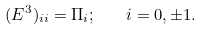Convert formula to latex. <formula><loc_0><loc_0><loc_500><loc_500>( E ^ { 3 } ) _ { i i } = \Pi _ { i } ; \quad i = 0 , \pm 1 .</formula> 